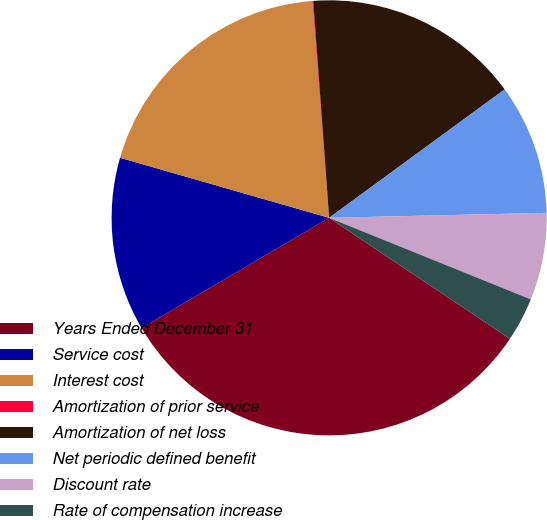<chart> <loc_0><loc_0><loc_500><loc_500><pie_chart><fcel>Years Ended December 31<fcel>Service cost<fcel>Interest cost<fcel>Amortization of prior service<fcel>Amortization of net loss<fcel>Net periodic defined benefit<fcel>Discount rate<fcel>Rate of compensation increase<nl><fcel>32.16%<fcel>12.9%<fcel>19.32%<fcel>0.06%<fcel>16.11%<fcel>9.69%<fcel>6.48%<fcel>3.27%<nl></chart> 